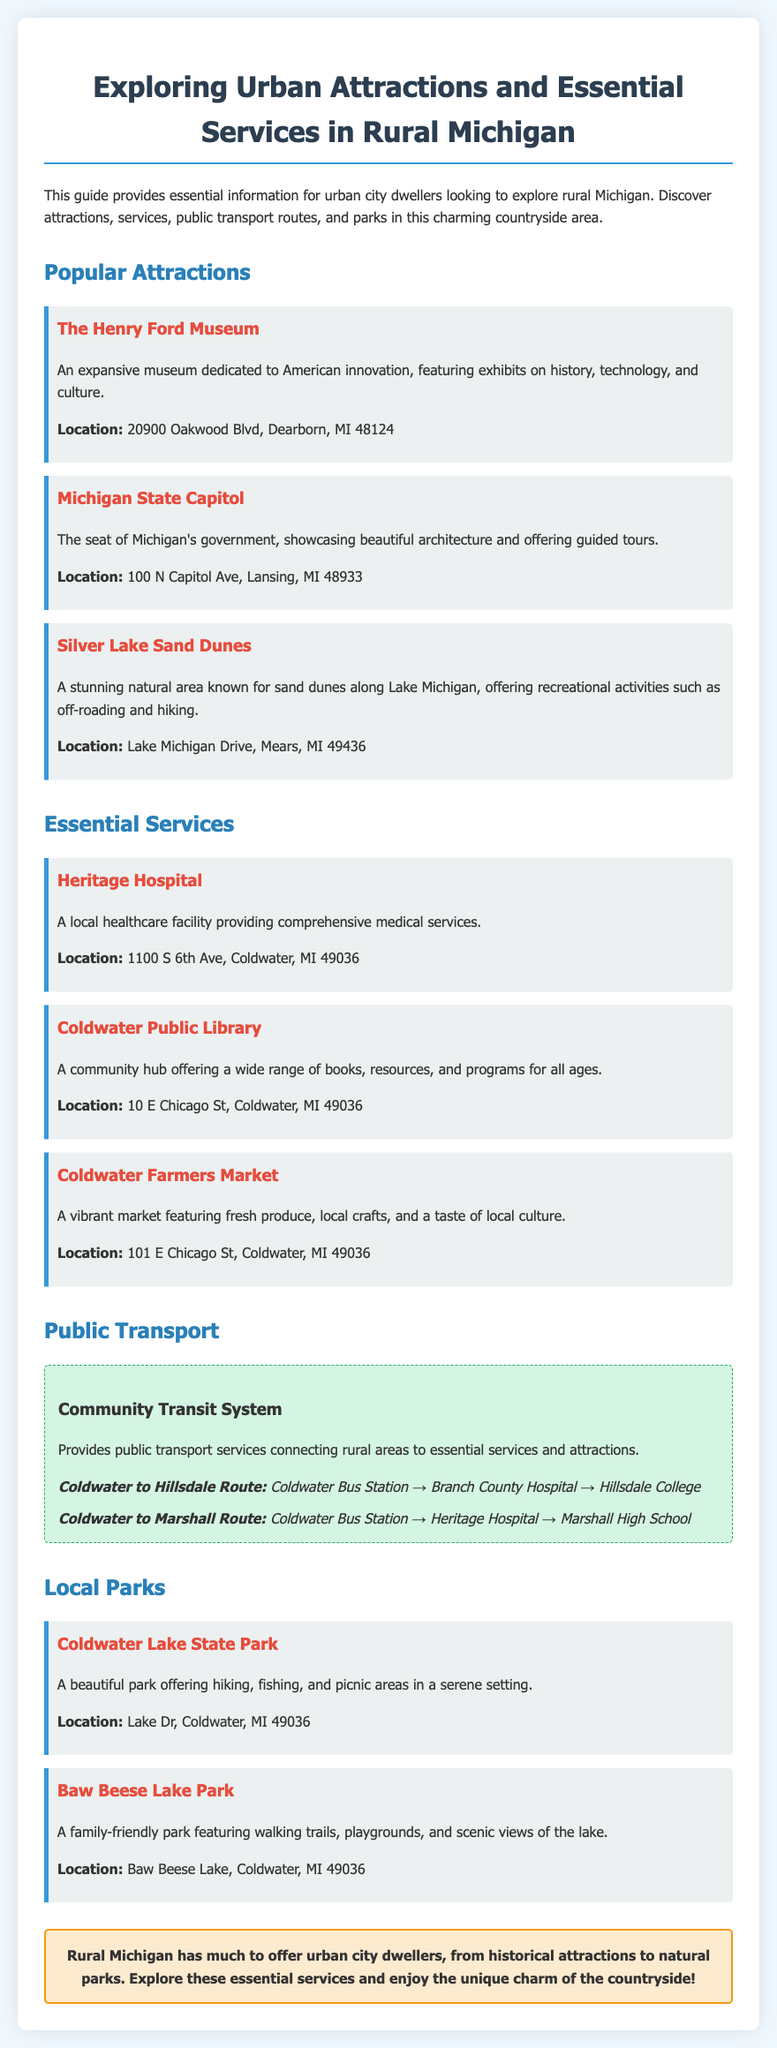What is the address of The Henry Ford Museum? The address can be found in the section about popular attractions.
Answer: 20900 Oakwood Blvd, Dearborn, MI 48124 What type of services does Heritage Hospital provide? This information is stated in the essential services section.
Answer: Comprehensive medical services Which park is known for walking trails and playgrounds? This question is answered by looking in the local parks section.
Answer: Baw Beese Lake Park What is the destination of the Coldwater to Hillsdale route? The route details are provided under public transport.
Answer: Hillsdale College How many attractions are listed in the document? To answer this, one must count the attractions listed in the document.
Answer: Three What natural feature is near Silver Lake Sand Dunes? The description of Silver Lake Sand Dunes provides this information.
Answer: Lake Michigan Which service is located at 10 E Chicago St? This information is retrieved from the essential services section.
Answer: Coldwater Public Library What is the purpose of the Community Transit System? The purpose is noted in the public transport section.
Answer: Provides public transport services 